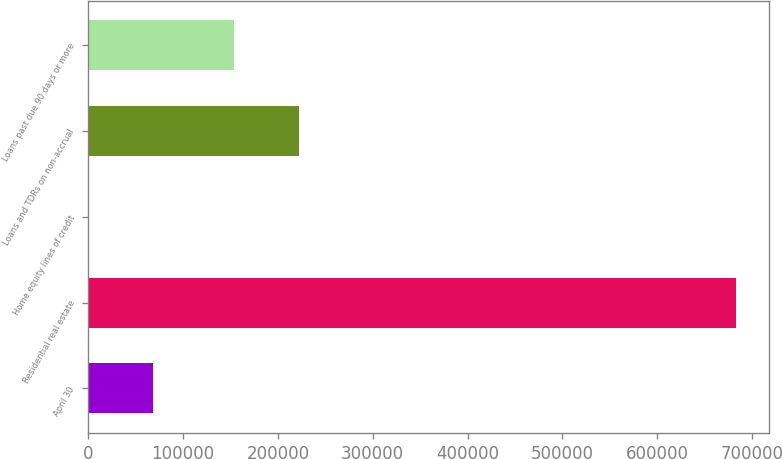Convert chart. <chart><loc_0><loc_0><loc_500><loc_500><bar_chart><fcel>April 30<fcel>Residential real estate<fcel>Home equity lines of credit<fcel>Loans and TDRs on non-accrual<fcel>Loans past due 90 days or more<nl><fcel>68554<fcel>683452<fcel>232<fcel>222025<fcel>153703<nl></chart> 